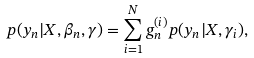Convert formula to latex. <formula><loc_0><loc_0><loc_500><loc_500>p ( y _ { n } | X , \beta _ { n } , \gamma ) = \sum _ { i = 1 } ^ { N } g _ { n } ^ { ( i ) } p ( y _ { n } | X , \gamma _ { i } ) ,</formula> 